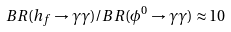Convert formula to latex. <formula><loc_0><loc_0><loc_500><loc_500>B R ( h _ { f } \to \gamma \gamma ) / B R ( \phi ^ { 0 } \to \gamma \gamma ) \approx 1 0</formula> 